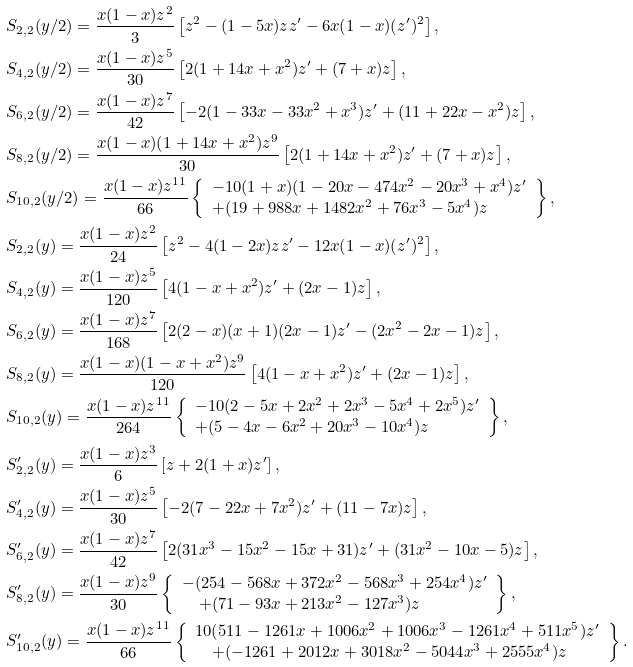<formula> <loc_0><loc_0><loc_500><loc_500>& S _ { 2 , 2 } ( y / 2 ) = \frac { x ( 1 - x ) z ^ { 2 } } { 3 } \left [ z ^ { 2 } - ( 1 - 5 x ) z z ^ { \prime } - 6 x ( 1 - x ) ( z ^ { \prime } ) ^ { 2 } \right ] , \\ & S _ { 4 , 2 } ( y / 2 ) = \frac { x ( 1 - x ) z ^ { 5 } } { 3 0 } \left [ 2 ( 1 + 1 4 x + x ^ { 2 } ) z ^ { \prime } + ( 7 + x ) z \right ] , \\ & S _ { 6 , 2 } ( y / 2 ) = \frac { x ( 1 - x ) z ^ { 7 } } { 4 2 } \left [ - 2 ( 1 - 3 3 x - 3 3 x ^ { 2 } + x ^ { 3 } ) z ^ { \prime } + ( 1 1 + 2 2 x - x ^ { 2 } ) z \right ] , \\ & S _ { 8 , 2 } ( y / 2 ) = \frac { x ( 1 - x ) ( 1 + 1 4 x + x ^ { 2 } ) z ^ { 9 } } { 3 0 } \left [ 2 ( 1 + 1 4 x + x ^ { 2 } ) z ^ { \prime } + ( 7 + x ) z \right ] , \\ & S _ { 1 0 , 2 } ( y / 2 ) = \frac { x ( 1 - x ) z ^ { 1 1 } } { 6 6 } \left \{ \begin{array} { l } - 1 0 ( 1 + x ) ( 1 - 2 0 x - 4 7 4 x ^ { 2 } - 2 0 x ^ { 3 } + x ^ { 4 } ) z ^ { \prime } \\ + ( 1 9 + 9 8 8 x + 1 4 8 2 x ^ { 2 } + 7 6 x ^ { 3 } - 5 x ^ { 4 } ) z \end{array} \right \} , \\ & S _ { 2 , 2 } ( y ) = \frac { x ( 1 - x ) z ^ { 2 } } { 2 4 } \left [ z ^ { 2 } - 4 ( 1 - 2 x ) z z ^ { \prime } - 1 2 x ( 1 - x ) ( z ^ { \prime } ) ^ { 2 } \right ] , \\ & S _ { 4 , 2 } ( y ) = \frac { x ( 1 - x ) z ^ { 5 } } { 1 2 0 } \left [ 4 ( 1 - x + x ^ { 2 } ) z ^ { \prime } + ( 2 x - 1 ) z \right ] , \\ & S _ { 6 , 2 } ( y ) = \frac { x ( 1 - x ) z ^ { 7 } } { 1 6 8 } \left [ 2 ( 2 - x ) ( x + 1 ) ( 2 x - 1 ) z ^ { \prime } - ( 2 x ^ { 2 } - 2 x - 1 ) z \right ] , \\ & S _ { 8 , 2 } ( y ) = \frac { x ( 1 - x ) ( 1 - x + x ^ { 2 } ) z ^ { 9 } } { 1 2 0 } \left [ 4 ( 1 - x + x ^ { 2 } ) z ^ { \prime } + ( 2 x - 1 ) z \right ] , \\ & S _ { 1 0 , 2 } ( y ) = \frac { x ( 1 - x ) z ^ { 1 1 } } { 2 6 4 } \left \{ \begin{array} { l } - 1 0 ( 2 - 5 x + 2 x ^ { 2 } + 2 x ^ { 3 } - 5 x ^ { 4 } + 2 x ^ { 5 } ) z ^ { \prime } \\ + ( 5 - 4 x - 6 x ^ { 2 } + 2 0 x ^ { 3 } - 1 0 x ^ { 4 } ) z \end{array} \right \} , \\ & S ^ { \prime } _ { 2 , 2 } ( y ) = \frac { x ( 1 - x ) z ^ { 3 } } { 6 } \left [ z + 2 ( 1 + x ) z ^ { \prime } \right ] , \\ & S ^ { \prime } _ { 4 , 2 } ( y ) = \frac { x ( 1 - x ) z ^ { 5 } } { 3 0 } \left [ - 2 ( 7 - 2 2 x + 7 x ^ { 2 } ) z ^ { \prime } + ( 1 1 - 7 x ) z \right ] , \\ & S ^ { \prime } _ { 6 , 2 } ( y ) = \frac { x ( 1 - x ) z ^ { 7 } } { 4 2 } \left [ 2 ( 3 1 x ^ { 3 } - 1 5 x ^ { 2 } - 1 5 x + 3 1 ) z ^ { \prime } + ( 3 1 x ^ { 2 } - 1 0 x - 5 ) z \right ] , \\ & S ^ { \prime } _ { 8 , 2 } ( y ) = \frac { x ( 1 - x ) z ^ { 9 } } { 3 0 } \left \{ \begin{array} { l } - ( 2 5 4 - 5 6 8 x + 3 7 2 x ^ { 2 } - 5 6 8 x ^ { 3 } + 2 5 4 x ^ { 4 } ) z ^ { \prime } \\ \quad + ( 7 1 - 9 3 x + 2 1 3 x ^ { 2 } - 1 2 7 x ^ { 3 } ) z \end{array} \right \} , \\ & S ^ { \prime } _ { 1 0 , 2 } ( y ) = \frac { x ( 1 - x ) z ^ { 1 1 } } { 6 6 } \left \{ \begin{array} { l } 1 0 ( 5 1 1 - 1 2 6 1 x + 1 0 0 6 x ^ { 2 } + 1 0 0 6 x ^ { 3 } - 1 2 6 1 x ^ { 4 } + 5 1 1 x ^ { 5 } ) z ^ { \prime } \\ \quad + ( - 1 2 6 1 + 2 0 1 2 x + 3 0 1 8 x ^ { 2 } - 5 0 4 4 x ^ { 3 } + 2 5 5 5 x ^ { 4 } ) z \end{array} \right \} .</formula> 